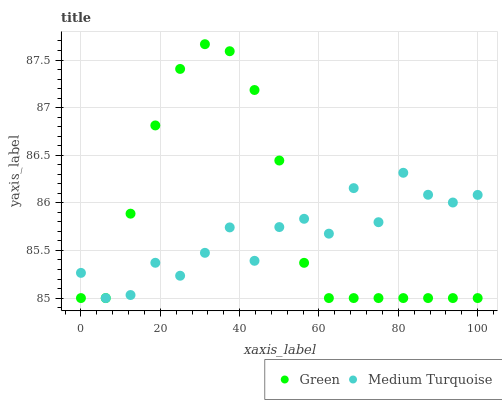Does Medium Turquoise have the minimum area under the curve?
Answer yes or no. Yes. Does Green have the maximum area under the curve?
Answer yes or no. Yes. Does Medium Turquoise have the maximum area under the curve?
Answer yes or no. No. Is Green the smoothest?
Answer yes or no. Yes. Is Medium Turquoise the roughest?
Answer yes or no. Yes. Is Medium Turquoise the smoothest?
Answer yes or no. No. Does Green have the lowest value?
Answer yes or no. Yes. Does Green have the highest value?
Answer yes or no. Yes. Does Medium Turquoise have the highest value?
Answer yes or no. No. Does Green intersect Medium Turquoise?
Answer yes or no. Yes. Is Green less than Medium Turquoise?
Answer yes or no. No. Is Green greater than Medium Turquoise?
Answer yes or no. No. 